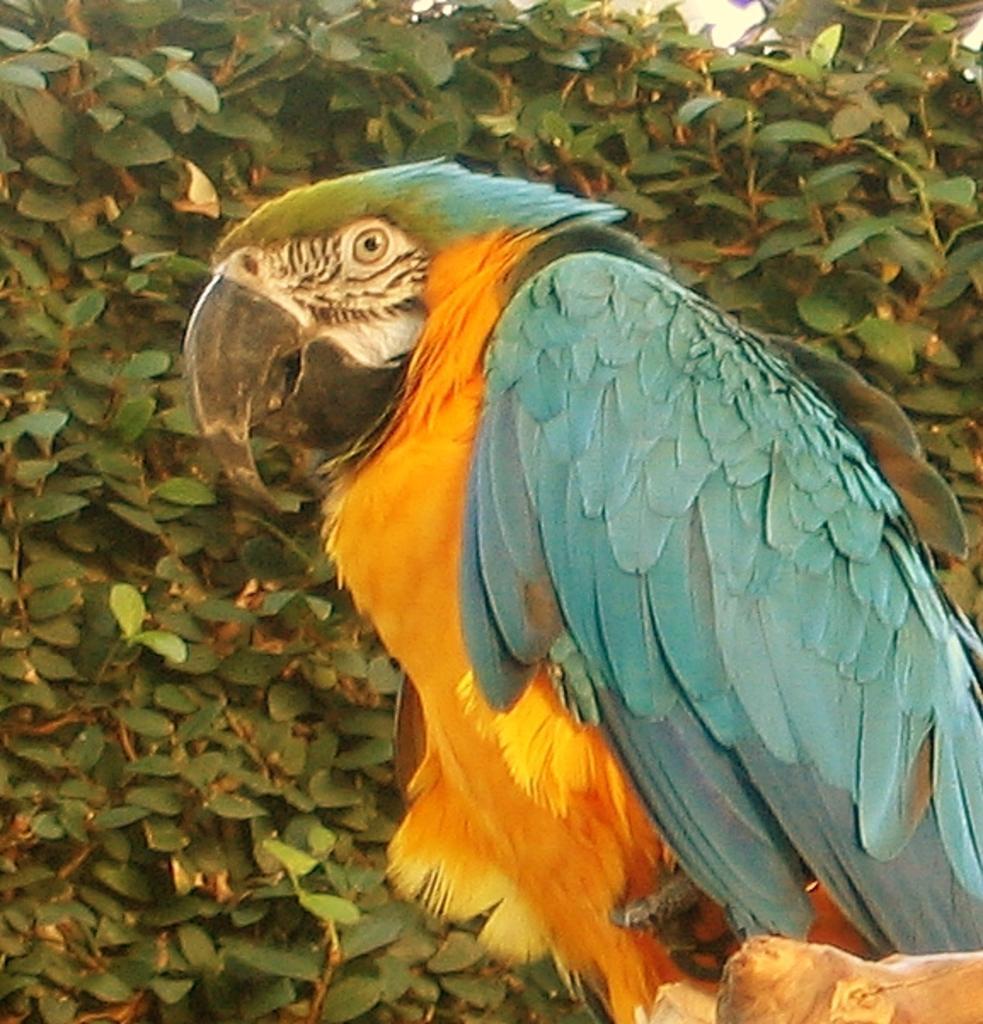In one or two sentences, can you explain what this image depicts? In the foreground of the picture there is a parrot sitting on stem of a tree. In the background there are leaves and stems. 